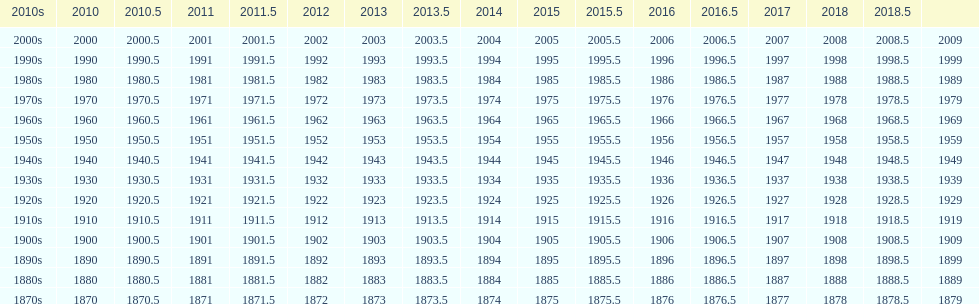True/false: all years go in consecutive order? True. 